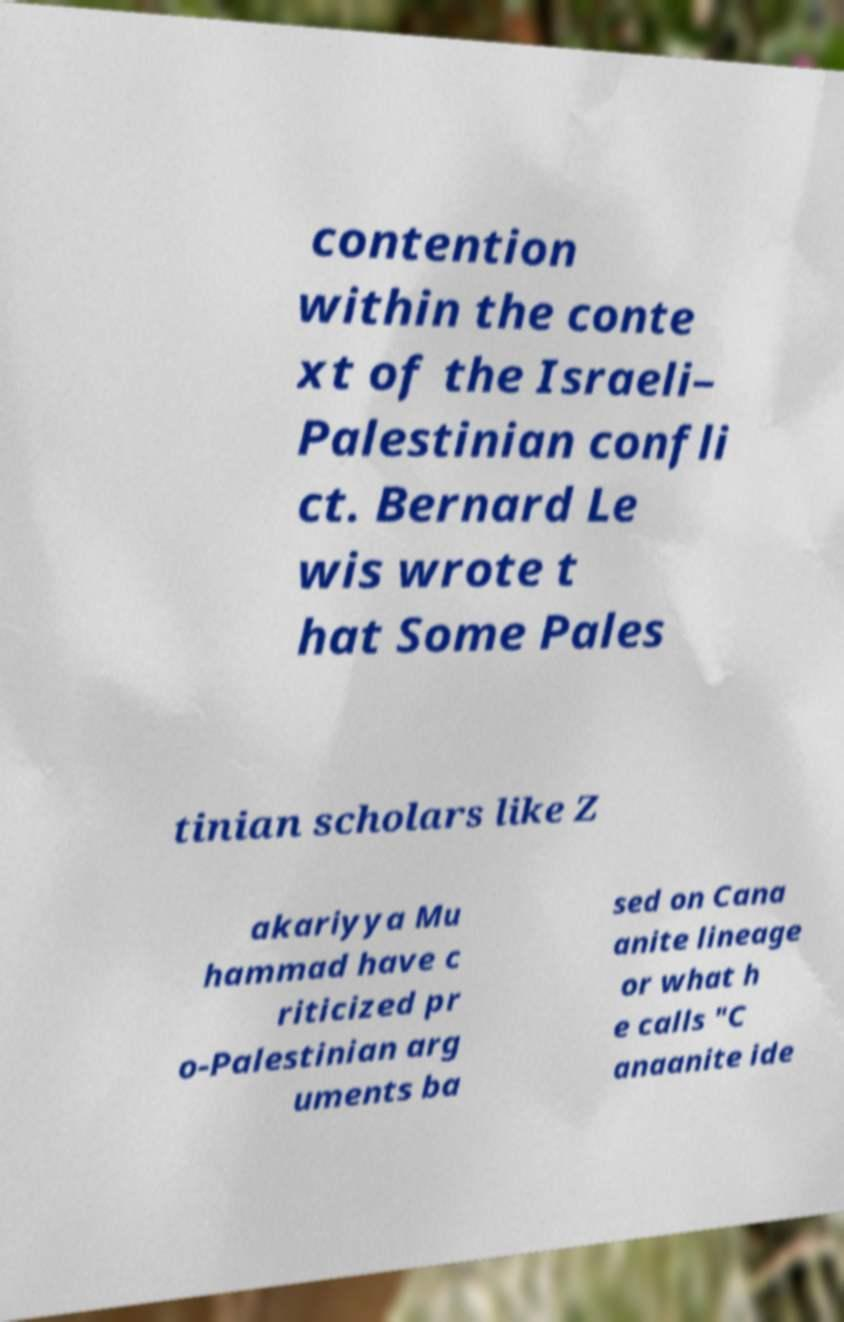Can you accurately transcribe the text from the provided image for me? contention within the conte xt of the Israeli– Palestinian confli ct. Bernard Le wis wrote t hat Some Pales tinian scholars like Z akariyya Mu hammad have c riticized pr o-Palestinian arg uments ba sed on Cana anite lineage or what h e calls "C anaanite ide 